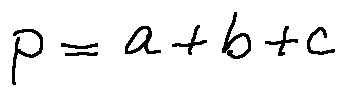<formula> <loc_0><loc_0><loc_500><loc_500>p = a + b + c</formula> 